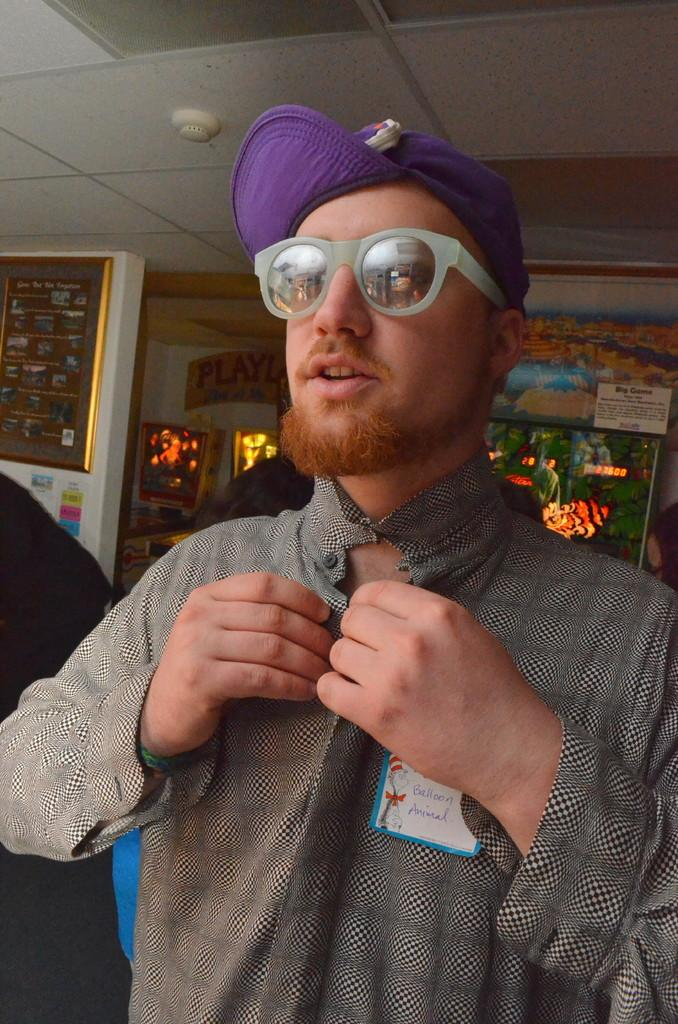Who is the main subject in the image? There is a boy in the image. What is the boy wearing on his upper body? The boy is wearing a black and white shirt. What type of headwear is the boy wearing? The boy is wearing a purple cap. What additional decorative elements can be seen in the image? There are decorative lights visible in the image. What can be seen hanging on the wall in the image? There is a golden photo frame on the wall in the image. How many clovers are visible in the image? There are no clovers present in the image. What type of knee support is the boy using in the image? The boy is not using any knee support in the image. 